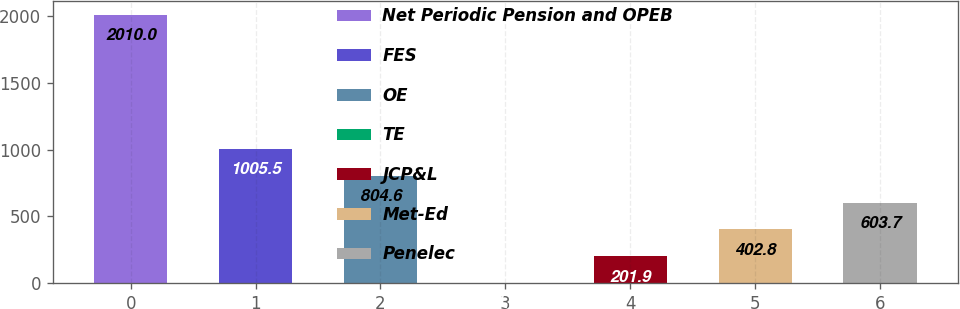Convert chart to OTSL. <chart><loc_0><loc_0><loc_500><loc_500><bar_chart><fcel>Net Periodic Pension and OPEB<fcel>FES<fcel>OE<fcel>TE<fcel>JCP&L<fcel>Met-Ed<fcel>Penelec<nl><fcel>2010<fcel>1005.5<fcel>804.6<fcel>1<fcel>201.9<fcel>402.8<fcel>603.7<nl></chart> 